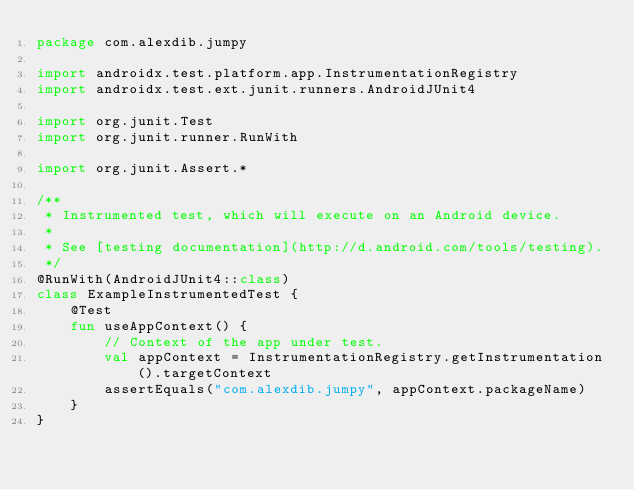<code> <loc_0><loc_0><loc_500><loc_500><_Kotlin_>package com.alexdib.jumpy

import androidx.test.platform.app.InstrumentationRegistry
import androidx.test.ext.junit.runners.AndroidJUnit4

import org.junit.Test
import org.junit.runner.RunWith

import org.junit.Assert.*

/**
 * Instrumented test, which will execute on an Android device.
 *
 * See [testing documentation](http://d.android.com/tools/testing).
 */
@RunWith(AndroidJUnit4::class)
class ExampleInstrumentedTest {
    @Test
    fun useAppContext() {
        // Context of the app under test.
        val appContext = InstrumentationRegistry.getInstrumentation().targetContext
        assertEquals("com.alexdib.jumpy", appContext.packageName)
    }
}
</code> 